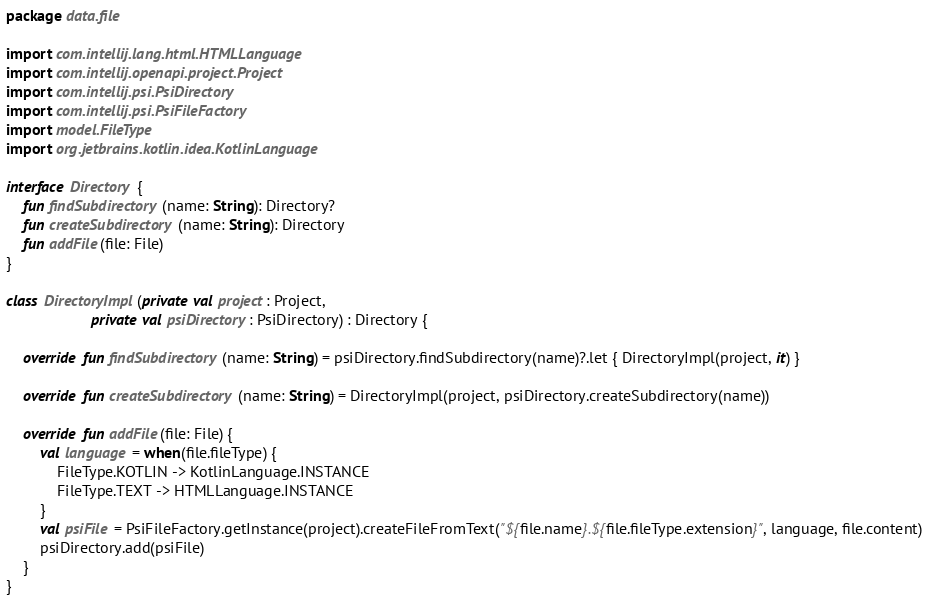Convert code to text. <code><loc_0><loc_0><loc_500><loc_500><_Kotlin_>package data.file

import com.intellij.lang.html.HTMLLanguage
import com.intellij.openapi.project.Project
import com.intellij.psi.PsiDirectory
import com.intellij.psi.PsiFileFactory
import model.FileType
import org.jetbrains.kotlin.idea.KotlinLanguage

interface Directory {
    fun findSubdirectory(name: String): Directory?
    fun createSubdirectory(name: String): Directory
    fun addFile(file: File)
}

class DirectoryImpl(private val project: Project,
                    private val psiDirectory: PsiDirectory) : Directory {

    override fun findSubdirectory(name: String) = psiDirectory.findSubdirectory(name)?.let { DirectoryImpl(project, it) }

    override fun createSubdirectory(name: String) = DirectoryImpl(project, psiDirectory.createSubdirectory(name))

    override fun addFile(file: File) {
        val language = when(file.fileType) {
            FileType.KOTLIN -> KotlinLanguage.INSTANCE
            FileType.TEXT -> HTMLLanguage.INSTANCE
        }
        val psiFile = PsiFileFactory.getInstance(project).createFileFromText("${file.name}.${file.fileType.extension}", language, file.content)
        psiDirectory.add(psiFile)
    }
}
</code> 